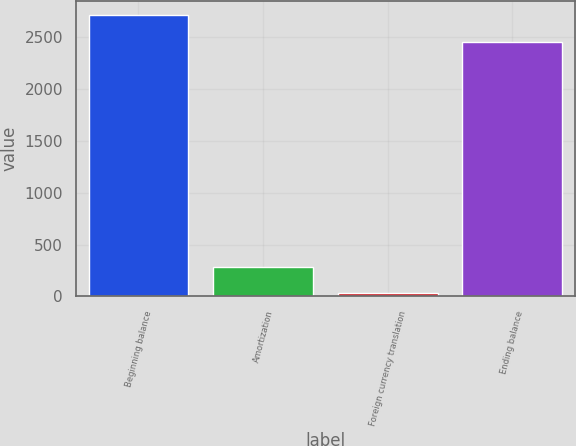Convert chart to OTSL. <chart><loc_0><loc_0><loc_500><loc_500><bar_chart><fcel>Beginning balance<fcel>Amortization<fcel>Foreign currency translation<fcel>Ending balance<nl><fcel>2715.3<fcel>286.3<fcel>30<fcel>2459<nl></chart> 